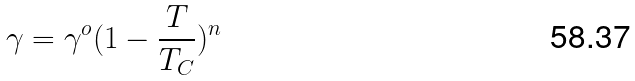Convert formula to latex. <formula><loc_0><loc_0><loc_500><loc_500>\gamma = \gamma ^ { o } ( 1 - \frac { T } { T _ { C } } ) ^ { n }</formula> 